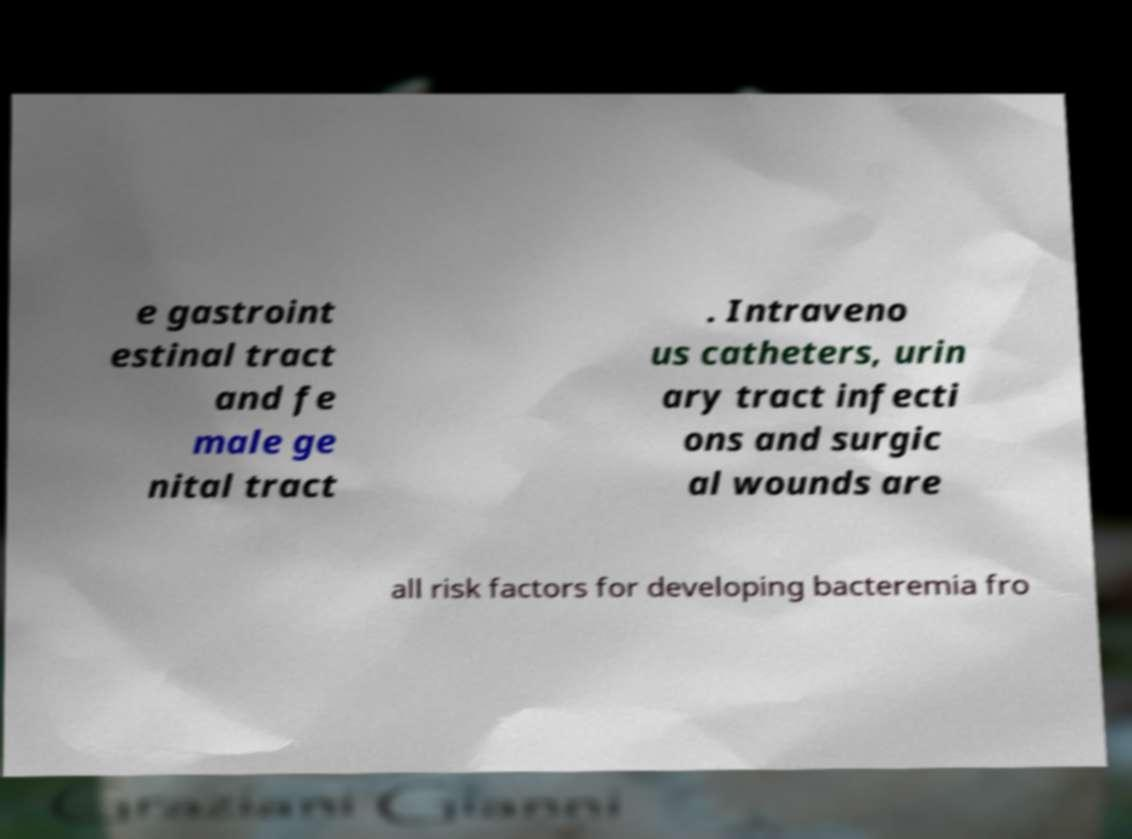There's text embedded in this image that I need extracted. Can you transcribe it verbatim? e gastroint estinal tract and fe male ge nital tract . Intraveno us catheters, urin ary tract infecti ons and surgic al wounds are all risk factors for developing bacteremia fro 